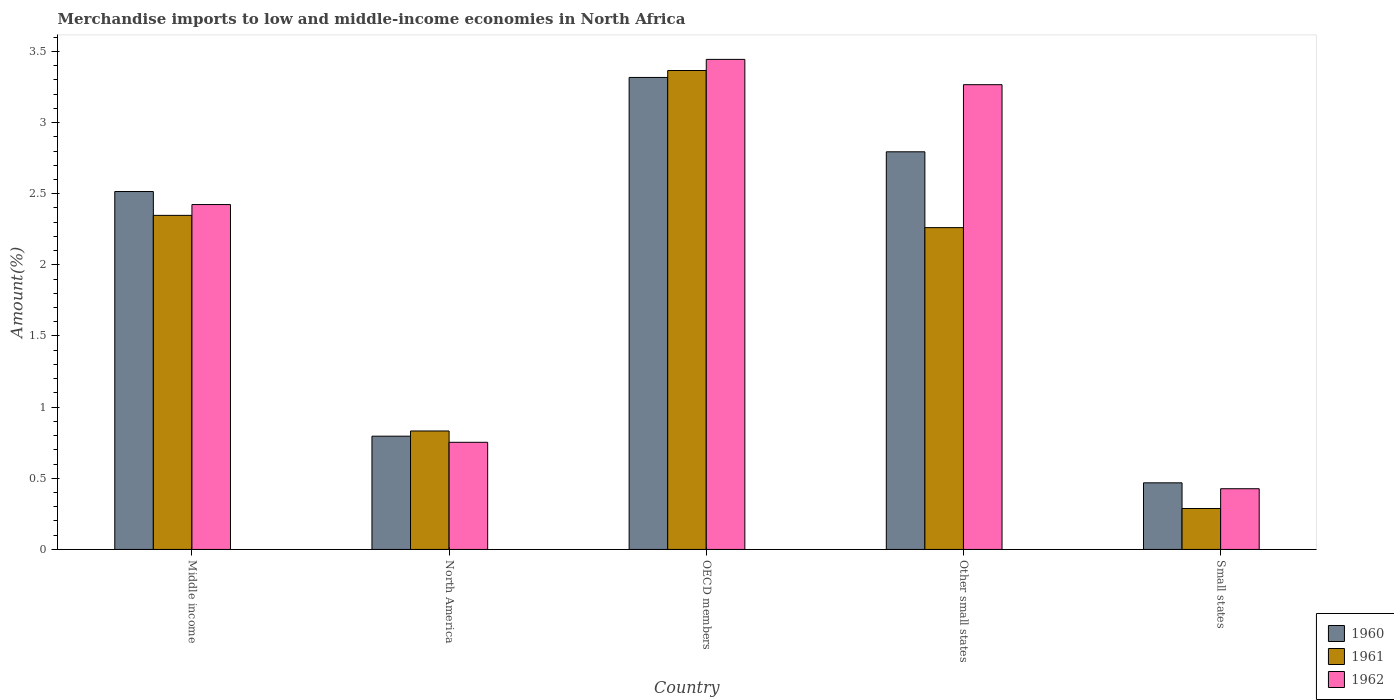How many different coloured bars are there?
Your response must be concise. 3. How many groups of bars are there?
Provide a short and direct response. 5. Are the number of bars on each tick of the X-axis equal?
Offer a terse response. Yes. How many bars are there on the 5th tick from the right?
Your answer should be compact. 3. What is the label of the 2nd group of bars from the left?
Give a very brief answer. North America. In how many cases, is the number of bars for a given country not equal to the number of legend labels?
Your response must be concise. 0. What is the percentage of amount earned from merchandise imports in 1961 in Middle income?
Give a very brief answer. 2.35. Across all countries, what is the maximum percentage of amount earned from merchandise imports in 1960?
Give a very brief answer. 3.32. Across all countries, what is the minimum percentage of amount earned from merchandise imports in 1962?
Your response must be concise. 0.43. In which country was the percentage of amount earned from merchandise imports in 1962 minimum?
Ensure brevity in your answer.  Small states. What is the total percentage of amount earned from merchandise imports in 1960 in the graph?
Provide a short and direct response. 9.89. What is the difference between the percentage of amount earned from merchandise imports in 1960 in Middle income and that in Small states?
Your response must be concise. 2.05. What is the difference between the percentage of amount earned from merchandise imports in 1962 in Small states and the percentage of amount earned from merchandise imports in 1961 in Middle income?
Make the answer very short. -1.92. What is the average percentage of amount earned from merchandise imports in 1961 per country?
Provide a succinct answer. 1.82. What is the difference between the percentage of amount earned from merchandise imports of/in 1960 and percentage of amount earned from merchandise imports of/in 1961 in North America?
Provide a short and direct response. -0.04. What is the ratio of the percentage of amount earned from merchandise imports in 1961 in OECD members to that in Other small states?
Provide a succinct answer. 1.49. What is the difference between the highest and the second highest percentage of amount earned from merchandise imports in 1962?
Provide a succinct answer. 0.84. What is the difference between the highest and the lowest percentage of amount earned from merchandise imports in 1960?
Offer a very short reply. 2.85. How many bars are there?
Your answer should be compact. 15. Are all the bars in the graph horizontal?
Provide a succinct answer. No. What is the difference between two consecutive major ticks on the Y-axis?
Make the answer very short. 0.5. Are the values on the major ticks of Y-axis written in scientific E-notation?
Offer a terse response. No. Does the graph contain grids?
Keep it short and to the point. No. How are the legend labels stacked?
Offer a very short reply. Vertical. What is the title of the graph?
Provide a short and direct response. Merchandise imports to low and middle-income economies in North Africa. What is the label or title of the Y-axis?
Your answer should be very brief. Amount(%). What is the Amount(%) of 1960 in Middle income?
Make the answer very short. 2.52. What is the Amount(%) in 1961 in Middle income?
Ensure brevity in your answer.  2.35. What is the Amount(%) of 1962 in Middle income?
Offer a terse response. 2.42. What is the Amount(%) in 1960 in North America?
Your answer should be compact. 0.8. What is the Amount(%) in 1961 in North America?
Your response must be concise. 0.83. What is the Amount(%) in 1962 in North America?
Your response must be concise. 0.75. What is the Amount(%) of 1960 in OECD members?
Provide a short and direct response. 3.32. What is the Amount(%) of 1961 in OECD members?
Make the answer very short. 3.37. What is the Amount(%) of 1962 in OECD members?
Offer a very short reply. 3.44. What is the Amount(%) in 1960 in Other small states?
Keep it short and to the point. 2.79. What is the Amount(%) of 1961 in Other small states?
Your answer should be compact. 2.26. What is the Amount(%) of 1962 in Other small states?
Your answer should be compact. 3.27. What is the Amount(%) of 1960 in Small states?
Provide a succinct answer. 0.47. What is the Amount(%) in 1961 in Small states?
Ensure brevity in your answer.  0.29. What is the Amount(%) of 1962 in Small states?
Your answer should be very brief. 0.43. Across all countries, what is the maximum Amount(%) of 1960?
Your answer should be compact. 3.32. Across all countries, what is the maximum Amount(%) of 1961?
Provide a short and direct response. 3.37. Across all countries, what is the maximum Amount(%) of 1962?
Offer a very short reply. 3.44. Across all countries, what is the minimum Amount(%) of 1960?
Your response must be concise. 0.47. Across all countries, what is the minimum Amount(%) of 1961?
Your answer should be very brief. 0.29. Across all countries, what is the minimum Amount(%) in 1962?
Ensure brevity in your answer.  0.43. What is the total Amount(%) of 1960 in the graph?
Keep it short and to the point. 9.89. What is the total Amount(%) of 1961 in the graph?
Make the answer very short. 9.1. What is the total Amount(%) of 1962 in the graph?
Your answer should be very brief. 10.31. What is the difference between the Amount(%) of 1960 in Middle income and that in North America?
Provide a short and direct response. 1.72. What is the difference between the Amount(%) of 1961 in Middle income and that in North America?
Ensure brevity in your answer.  1.52. What is the difference between the Amount(%) in 1962 in Middle income and that in North America?
Ensure brevity in your answer.  1.67. What is the difference between the Amount(%) in 1960 in Middle income and that in OECD members?
Give a very brief answer. -0.8. What is the difference between the Amount(%) in 1961 in Middle income and that in OECD members?
Provide a short and direct response. -1.02. What is the difference between the Amount(%) of 1962 in Middle income and that in OECD members?
Provide a short and direct response. -1.02. What is the difference between the Amount(%) of 1960 in Middle income and that in Other small states?
Make the answer very short. -0.28. What is the difference between the Amount(%) of 1961 in Middle income and that in Other small states?
Keep it short and to the point. 0.09. What is the difference between the Amount(%) in 1962 in Middle income and that in Other small states?
Your answer should be very brief. -0.84. What is the difference between the Amount(%) in 1960 in Middle income and that in Small states?
Offer a terse response. 2.05. What is the difference between the Amount(%) of 1961 in Middle income and that in Small states?
Give a very brief answer. 2.06. What is the difference between the Amount(%) of 1962 in Middle income and that in Small states?
Your answer should be very brief. 2. What is the difference between the Amount(%) in 1960 in North America and that in OECD members?
Offer a terse response. -2.52. What is the difference between the Amount(%) in 1961 in North America and that in OECD members?
Your response must be concise. -2.53. What is the difference between the Amount(%) in 1962 in North America and that in OECD members?
Keep it short and to the point. -2.69. What is the difference between the Amount(%) of 1960 in North America and that in Other small states?
Ensure brevity in your answer.  -2. What is the difference between the Amount(%) of 1961 in North America and that in Other small states?
Provide a succinct answer. -1.43. What is the difference between the Amount(%) of 1962 in North America and that in Other small states?
Offer a very short reply. -2.51. What is the difference between the Amount(%) of 1960 in North America and that in Small states?
Your response must be concise. 0.33. What is the difference between the Amount(%) of 1961 in North America and that in Small states?
Offer a very short reply. 0.54. What is the difference between the Amount(%) in 1962 in North America and that in Small states?
Your answer should be compact. 0.33. What is the difference between the Amount(%) in 1960 in OECD members and that in Other small states?
Give a very brief answer. 0.52. What is the difference between the Amount(%) of 1961 in OECD members and that in Other small states?
Provide a short and direct response. 1.1. What is the difference between the Amount(%) in 1962 in OECD members and that in Other small states?
Make the answer very short. 0.18. What is the difference between the Amount(%) in 1960 in OECD members and that in Small states?
Ensure brevity in your answer.  2.85. What is the difference between the Amount(%) in 1961 in OECD members and that in Small states?
Offer a terse response. 3.08. What is the difference between the Amount(%) of 1962 in OECD members and that in Small states?
Offer a very short reply. 3.02. What is the difference between the Amount(%) in 1960 in Other small states and that in Small states?
Your answer should be compact. 2.33. What is the difference between the Amount(%) in 1961 in Other small states and that in Small states?
Your answer should be compact. 1.97. What is the difference between the Amount(%) of 1962 in Other small states and that in Small states?
Provide a succinct answer. 2.84. What is the difference between the Amount(%) of 1960 in Middle income and the Amount(%) of 1961 in North America?
Give a very brief answer. 1.68. What is the difference between the Amount(%) in 1960 in Middle income and the Amount(%) in 1962 in North America?
Give a very brief answer. 1.76. What is the difference between the Amount(%) of 1961 in Middle income and the Amount(%) of 1962 in North America?
Your answer should be compact. 1.59. What is the difference between the Amount(%) in 1960 in Middle income and the Amount(%) in 1961 in OECD members?
Your response must be concise. -0.85. What is the difference between the Amount(%) of 1960 in Middle income and the Amount(%) of 1962 in OECD members?
Provide a short and direct response. -0.93. What is the difference between the Amount(%) in 1961 in Middle income and the Amount(%) in 1962 in OECD members?
Your response must be concise. -1.1. What is the difference between the Amount(%) in 1960 in Middle income and the Amount(%) in 1961 in Other small states?
Your answer should be compact. 0.25. What is the difference between the Amount(%) in 1960 in Middle income and the Amount(%) in 1962 in Other small states?
Provide a succinct answer. -0.75. What is the difference between the Amount(%) of 1961 in Middle income and the Amount(%) of 1962 in Other small states?
Offer a very short reply. -0.92. What is the difference between the Amount(%) in 1960 in Middle income and the Amount(%) in 1961 in Small states?
Provide a succinct answer. 2.23. What is the difference between the Amount(%) in 1960 in Middle income and the Amount(%) in 1962 in Small states?
Offer a terse response. 2.09. What is the difference between the Amount(%) in 1961 in Middle income and the Amount(%) in 1962 in Small states?
Offer a terse response. 1.92. What is the difference between the Amount(%) of 1960 in North America and the Amount(%) of 1961 in OECD members?
Offer a very short reply. -2.57. What is the difference between the Amount(%) of 1960 in North America and the Amount(%) of 1962 in OECD members?
Make the answer very short. -2.65. What is the difference between the Amount(%) of 1961 in North America and the Amount(%) of 1962 in OECD members?
Offer a very short reply. -2.61. What is the difference between the Amount(%) of 1960 in North America and the Amount(%) of 1961 in Other small states?
Offer a terse response. -1.47. What is the difference between the Amount(%) of 1960 in North America and the Amount(%) of 1962 in Other small states?
Your answer should be very brief. -2.47. What is the difference between the Amount(%) of 1961 in North America and the Amount(%) of 1962 in Other small states?
Your answer should be compact. -2.43. What is the difference between the Amount(%) of 1960 in North America and the Amount(%) of 1961 in Small states?
Offer a very short reply. 0.51. What is the difference between the Amount(%) of 1960 in North America and the Amount(%) of 1962 in Small states?
Your response must be concise. 0.37. What is the difference between the Amount(%) of 1961 in North America and the Amount(%) of 1962 in Small states?
Offer a very short reply. 0.41. What is the difference between the Amount(%) in 1960 in OECD members and the Amount(%) in 1961 in Other small states?
Offer a terse response. 1.06. What is the difference between the Amount(%) of 1960 in OECD members and the Amount(%) of 1962 in Other small states?
Your response must be concise. 0.05. What is the difference between the Amount(%) of 1961 in OECD members and the Amount(%) of 1962 in Other small states?
Offer a terse response. 0.1. What is the difference between the Amount(%) in 1960 in OECD members and the Amount(%) in 1961 in Small states?
Ensure brevity in your answer.  3.03. What is the difference between the Amount(%) in 1960 in OECD members and the Amount(%) in 1962 in Small states?
Give a very brief answer. 2.89. What is the difference between the Amount(%) of 1961 in OECD members and the Amount(%) of 1962 in Small states?
Provide a short and direct response. 2.94. What is the difference between the Amount(%) of 1960 in Other small states and the Amount(%) of 1961 in Small states?
Offer a very short reply. 2.51. What is the difference between the Amount(%) in 1960 in Other small states and the Amount(%) in 1962 in Small states?
Make the answer very short. 2.37. What is the difference between the Amount(%) in 1961 in Other small states and the Amount(%) in 1962 in Small states?
Provide a short and direct response. 1.83. What is the average Amount(%) of 1960 per country?
Offer a very short reply. 1.98. What is the average Amount(%) in 1961 per country?
Make the answer very short. 1.82. What is the average Amount(%) in 1962 per country?
Your response must be concise. 2.06. What is the difference between the Amount(%) of 1960 and Amount(%) of 1961 in Middle income?
Ensure brevity in your answer.  0.17. What is the difference between the Amount(%) of 1960 and Amount(%) of 1962 in Middle income?
Your response must be concise. 0.09. What is the difference between the Amount(%) in 1961 and Amount(%) in 1962 in Middle income?
Give a very brief answer. -0.08. What is the difference between the Amount(%) of 1960 and Amount(%) of 1961 in North America?
Offer a terse response. -0.04. What is the difference between the Amount(%) of 1960 and Amount(%) of 1962 in North America?
Offer a very short reply. 0.04. What is the difference between the Amount(%) in 1961 and Amount(%) in 1962 in North America?
Your answer should be compact. 0.08. What is the difference between the Amount(%) of 1960 and Amount(%) of 1961 in OECD members?
Make the answer very short. -0.05. What is the difference between the Amount(%) of 1960 and Amount(%) of 1962 in OECD members?
Make the answer very short. -0.13. What is the difference between the Amount(%) in 1961 and Amount(%) in 1962 in OECD members?
Your answer should be compact. -0.08. What is the difference between the Amount(%) in 1960 and Amount(%) in 1961 in Other small states?
Provide a short and direct response. 0.53. What is the difference between the Amount(%) in 1960 and Amount(%) in 1962 in Other small states?
Provide a succinct answer. -0.47. What is the difference between the Amount(%) of 1961 and Amount(%) of 1962 in Other small states?
Keep it short and to the point. -1. What is the difference between the Amount(%) in 1960 and Amount(%) in 1961 in Small states?
Your answer should be very brief. 0.18. What is the difference between the Amount(%) in 1960 and Amount(%) in 1962 in Small states?
Ensure brevity in your answer.  0.04. What is the difference between the Amount(%) in 1961 and Amount(%) in 1962 in Small states?
Ensure brevity in your answer.  -0.14. What is the ratio of the Amount(%) of 1960 in Middle income to that in North America?
Give a very brief answer. 3.16. What is the ratio of the Amount(%) in 1961 in Middle income to that in North America?
Keep it short and to the point. 2.82. What is the ratio of the Amount(%) in 1962 in Middle income to that in North America?
Your response must be concise. 3.22. What is the ratio of the Amount(%) in 1960 in Middle income to that in OECD members?
Your answer should be compact. 0.76. What is the ratio of the Amount(%) in 1961 in Middle income to that in OECD members?
Ensure brevity in your answer.  0.7. What is the ratio of the Amount(%) in 1962 in Middle income to that in OECD members?
Your response must be concise. 0.7. What is the ratio of the Amount(%) in 1960 in Middle income to that in Other small states?
Provide a short and direct response. 0.9. What is the ratio of the Amount(%) in 1961 in Middle income to that in Other small states?
Your answer should be very brief. 1.04. What is the ratio of the Amount(%) of 1962 in Middle income to that in Other small states?
Provide a succinct answer. 0.74. What is the ratio of the Amount(%) of 1960 in Middle income to that in Small states?
Your response must be concise. 5.37. What is the ratio of the Amount(%) of 1961 in Middle income to that in Small states?
Make the answer very short. 8.16. What is the ratio of the Amount(%) in 1962 in Middle income to that in Small states?
Your answer should be very brief. 5.68. What is the ratio of the Amount(%) of 1960 in North America to that in OECD members?
Ensure brevity in your answer.  0.24. What is the ratio of the Amount(%) of 1961 in North America to that in OECD members?
Provide a succinct answer. 0.25. What is the ratio of the Amount(%) of 1962 in North America to that in OECD members?
Give a very brief answer. 0.22. What is the ratio of the Amount(%) of 1960 in North America to that in Other small states?
Make the answer very short. 0.28. What is the ratio of the Amount(%) in 1961 in North America to that in Other small states?
Ensure brevity in your answer.  0.37. What is the ratio of the Amount(%) of 1962 in North America to that in Other small states?
Your response must be concise. 0.23. What is the ratio of the Amount(%) of 1960 in North America to that in Small states?
Your response must be concise. 1.7. What is the ratio of the Amount(%) of 1961 in North America to that in Small states?
Offer a very short reply. 2.89. What is the ratio of the Amount(%) in 1962 in North America to that in Small states?
Your answer should be compact. 1.76. What is the ratio of the Amount(%) in 1960 in OECD members to that in Other small states?
Your answer should be very brief. 1.19. What is the ratio of the Amount(%) of 1961 in OECD members to that in Other small states?
Provide a succinct answer. 1.49. What is the ratio of the Amount(%) in 1962 in OECD members to that in Other small states?
Your answer should be very brief. 1.05. What is the ratio of the Amount(%) of 1960 in OECD members to that in Small states?
Provide a short and direct response. 7.09. What is the ratio of the Amount(%) of 1961 in OECD members to that in Small states?
Ensure brevity in your answer.  11.69. What is the ratio of the Amount(%) in 1962 in OECD members to that in Small states?
Your response must be concise. 8.07. What is the ratio of the Amount(%) of 1960 in Other small states to that in Small states?
Provide a short and direct response. 5.97. What is the ratio of the Amount(%) of 1961 in Other small states to that in Small states?
Your response must be concise. 7.86. What is the ratio of the Amount(%) of 1962 in Other small states to that in Small states?
Ensure brevity in your answer.  7.65. What is the difference between the highest and the second highest Amount(%) of 1960?
Offer a very short reply. 0.52. What is the difference between the highest and the second highest Amount(%) of 1961?
Provide a succinct answer. 1.02. What is the difference between the highest and the second highest Amount(%) in 1962?
Ensure brevity in your answer.  0.18. What is the difference between the highest and the lowest Amount(%) of 1960?
Your response must be concise. 2.85. What is the difference between the highest and the lowest Amount(%) in 1961?
Give a very brief answer. 3.08. What is the difference between the highest and the lowest Amount(%) in 1962?
Offer a terse response. 3.02. 